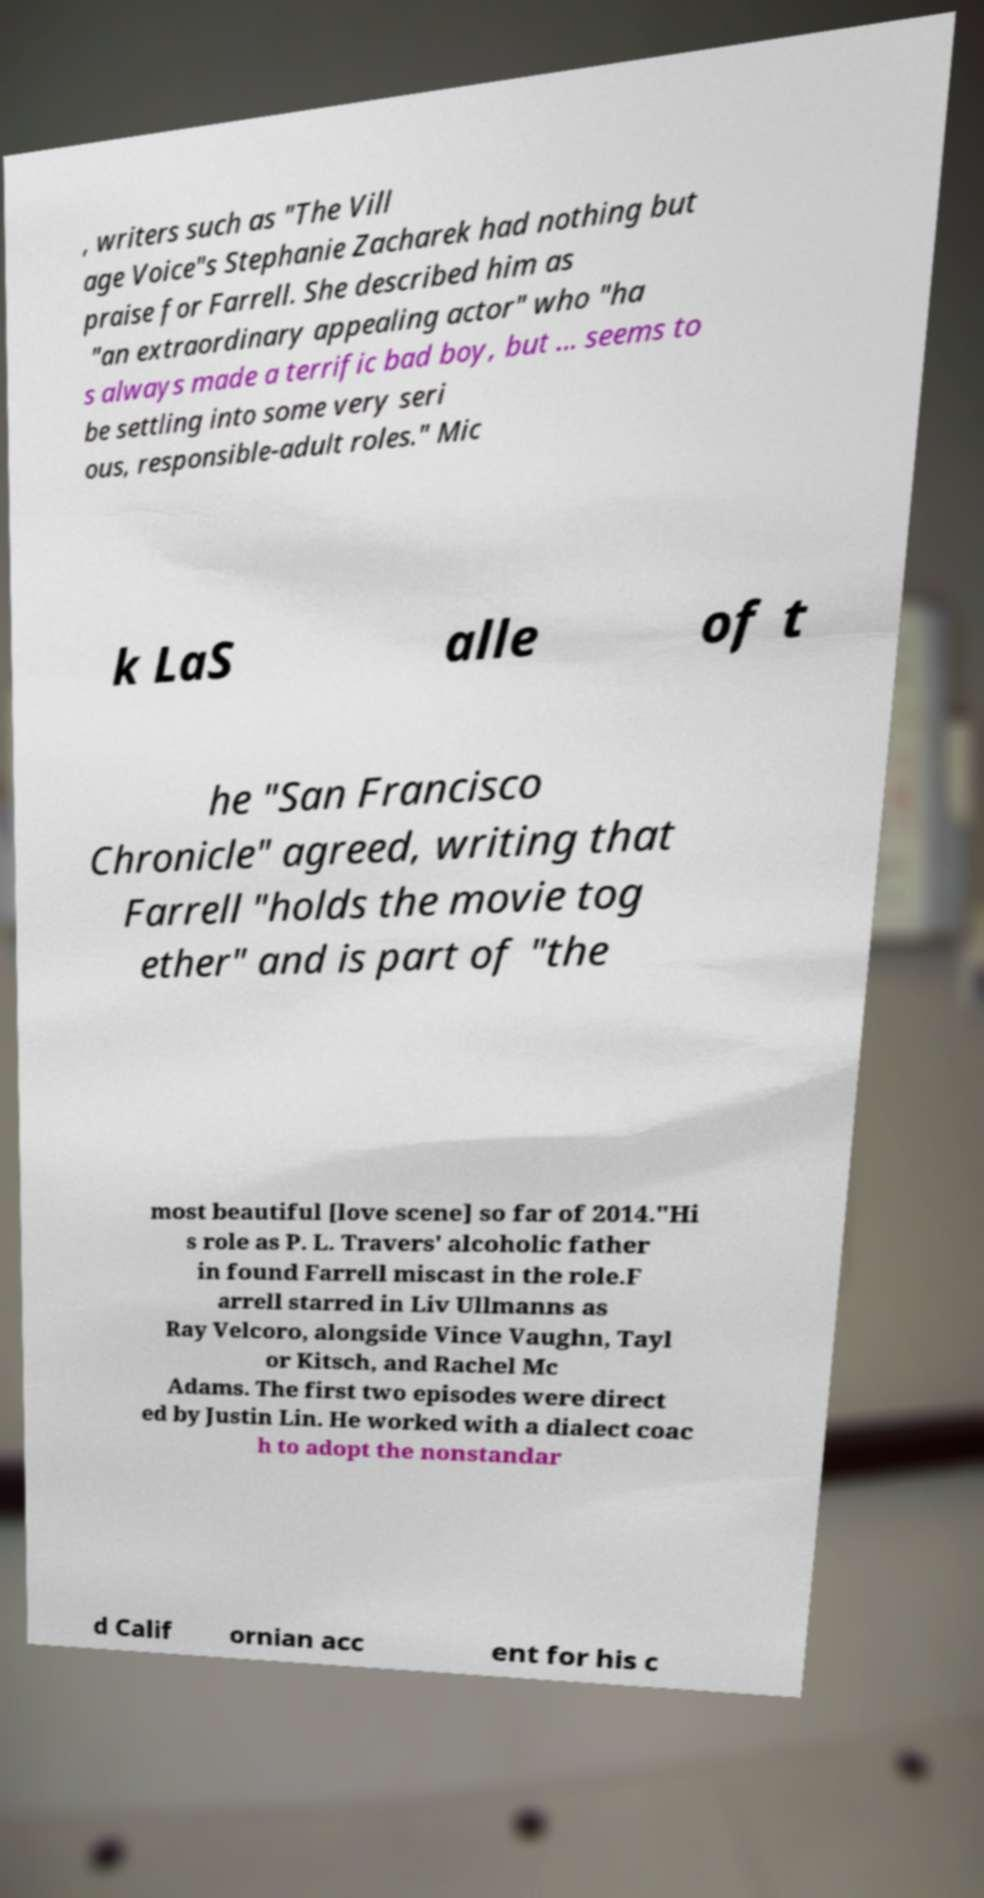For documentation purposes, I need the text within this image transcribed. Could you provide that? , writers such as "The Vill age Voice"s Stephanie Zacharek had nothing but praise for Farrell. She described him as "an extraordinary appealing actor" who "ha s always made a terrific bad boy, but ... seems to be settling into some very seri ous, responsible-adult roles." Mic k LaS alle of t he "San Francisco Chronicle" agreed, writing that Farrell "holds the movie tog ether" and is part of "the most beautiful [love scene] so far of 2014."Hi s role as P. L. Travers' alcoholic father in found Farrell miscast in the role.F arrell starred in Liv Ullmanns as Ray Velcoro, alongside Vince Vaughn, Tayl or Kitsch, and Rachel Mc Adams. The first two episodes were direct ed by Justin Lin. He worked with a dialect coac h to adopt the nonstandar d Calif ornian acc ent for his c 